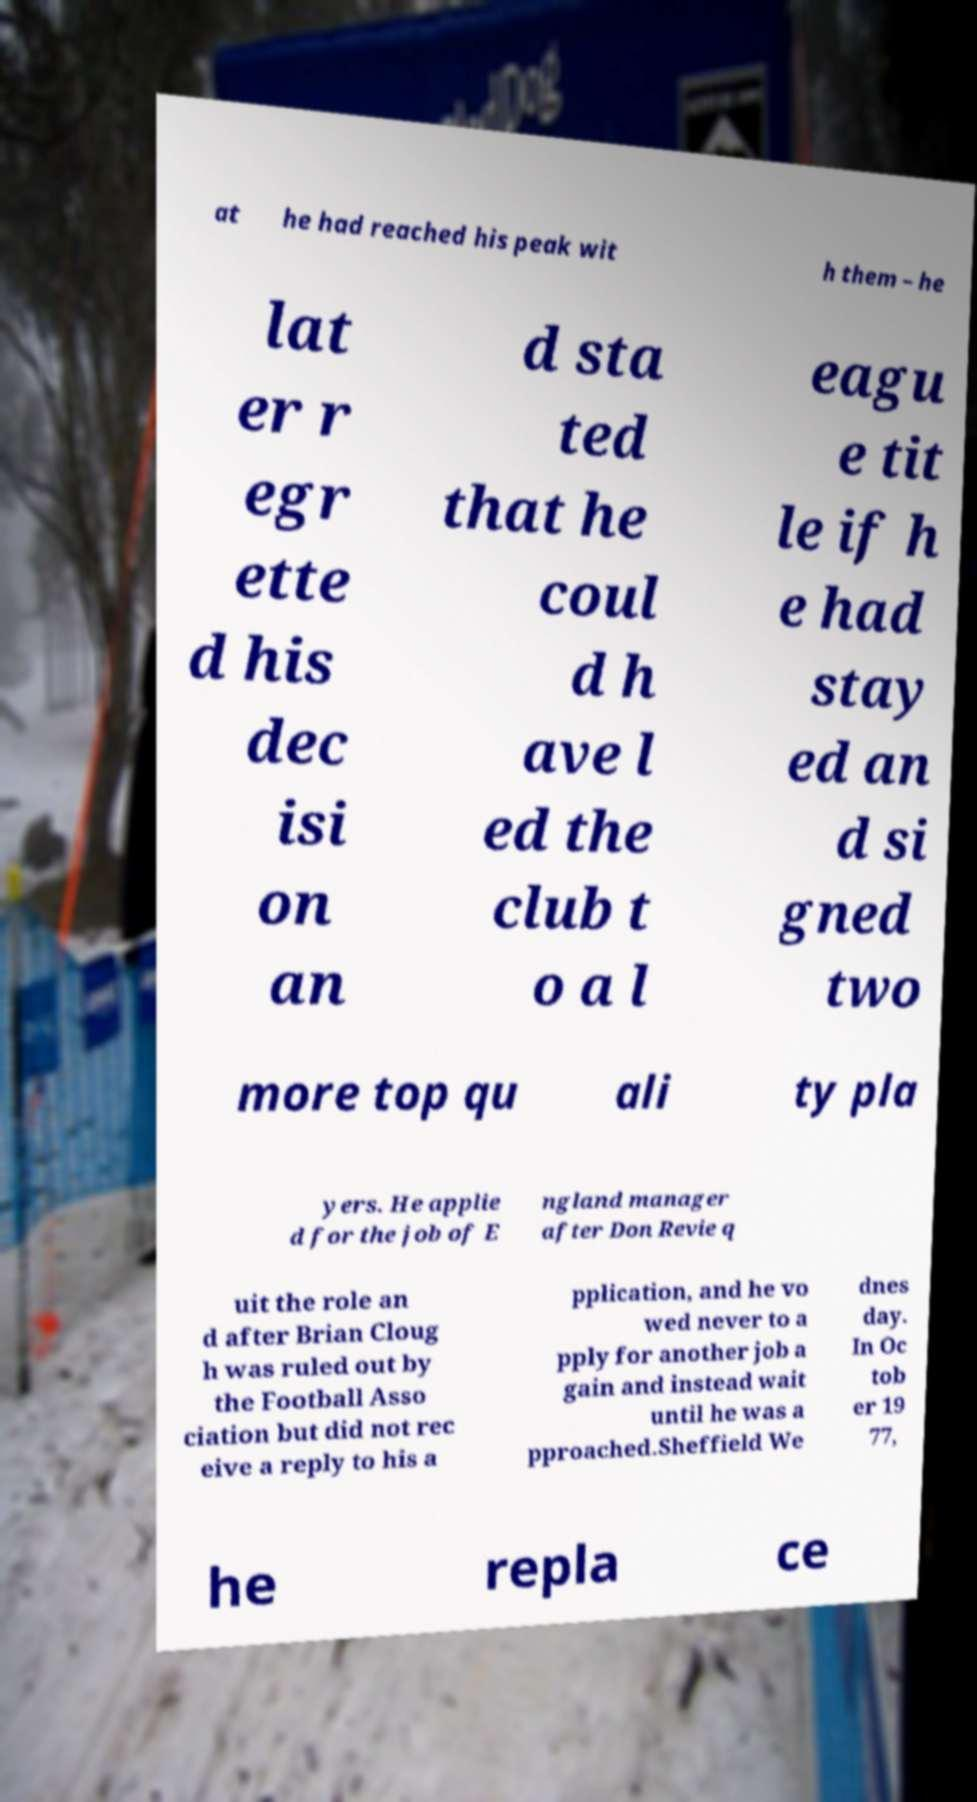I need the written content from this picture converted into text. Can you do that? at he had reached his peak wit h them – he lat er r egr ette d his dec isi on an d sta ted that he coul d h ave l ed the club t o a l eagu e tit le if h e had stay ed an d si gned two more top qu ali ty pla yers. He applie d for the job of E ngland manager after Don Revie q uit the role an d after Brian Cloug h was ruled out by the Football Asso ciation but did not rec eive a reply to his a pplication, and he vo wed never to a pply for another job a gain and instead wait until he was a pproached.Sheffield We dnes day. In Oc tob er 19 77, he repla ce 